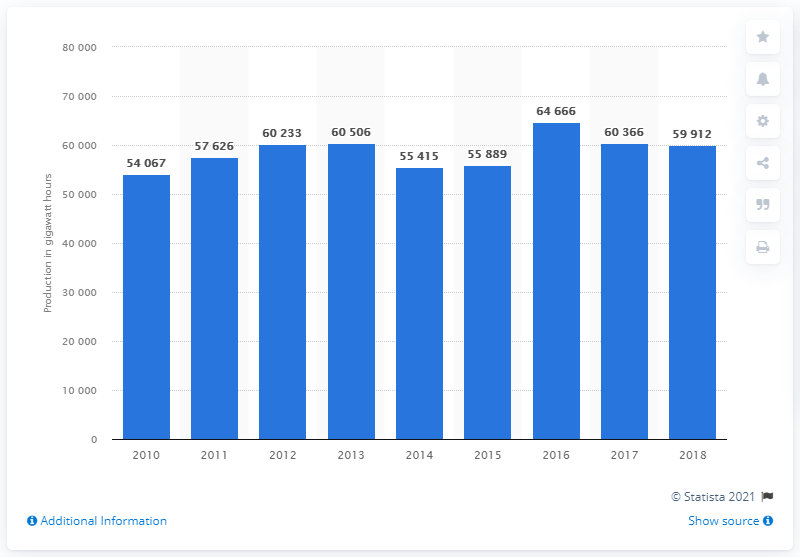List a handful of essential elements in this visual. Paraguay reached the peak of the decade in 2016. 